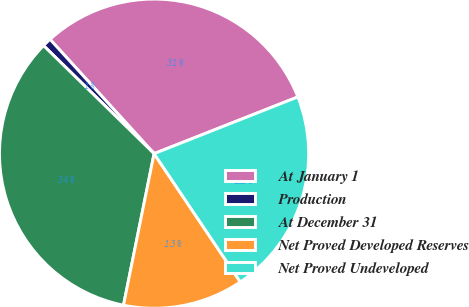Convert chart. <chart><loc_0><loc_0><loc_500><loc_500><pie_chart><fcel>At January 1<fcel>Production<fcel>At December 31<fcel>Net Proved Developed Reserves<fcel>Net Proved Undeveloped<nl><fcel>30.77%<fcel>0.93%<fcel>34.15%<fcel>12.59%<fcel>21.56%<nl></chart> 